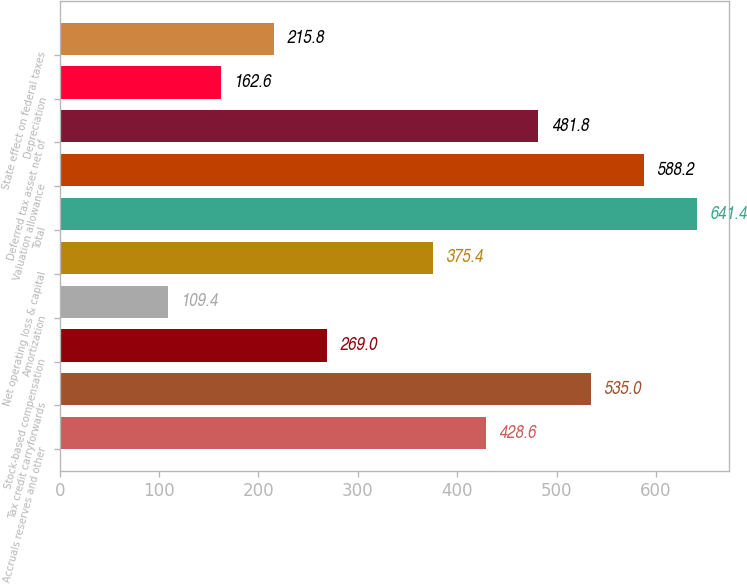Convert chart to OTSL. <chart><loc_0><loc_0><loc_500><loc_500><bar_chart><fcel>Accruals reserves and other<fcel>Tax credit carryforwards<fcel>Stock-based compensation<fcel>Amortization<fcel>Net operating loss & capital<fcel>Total<fcel>Valuation allowance<fcel>Deferred tax asset net of<fcel>Depreciation<fcel>State effect on federal taxes<nl><fcel>428.6<fcel>535<fcel>269<fcel>109.4<fcel>375.4<fcel>641.4<fcel>588.2<fcel>481.8<fcel>162.6<fcel>215.8<nl></chart> 